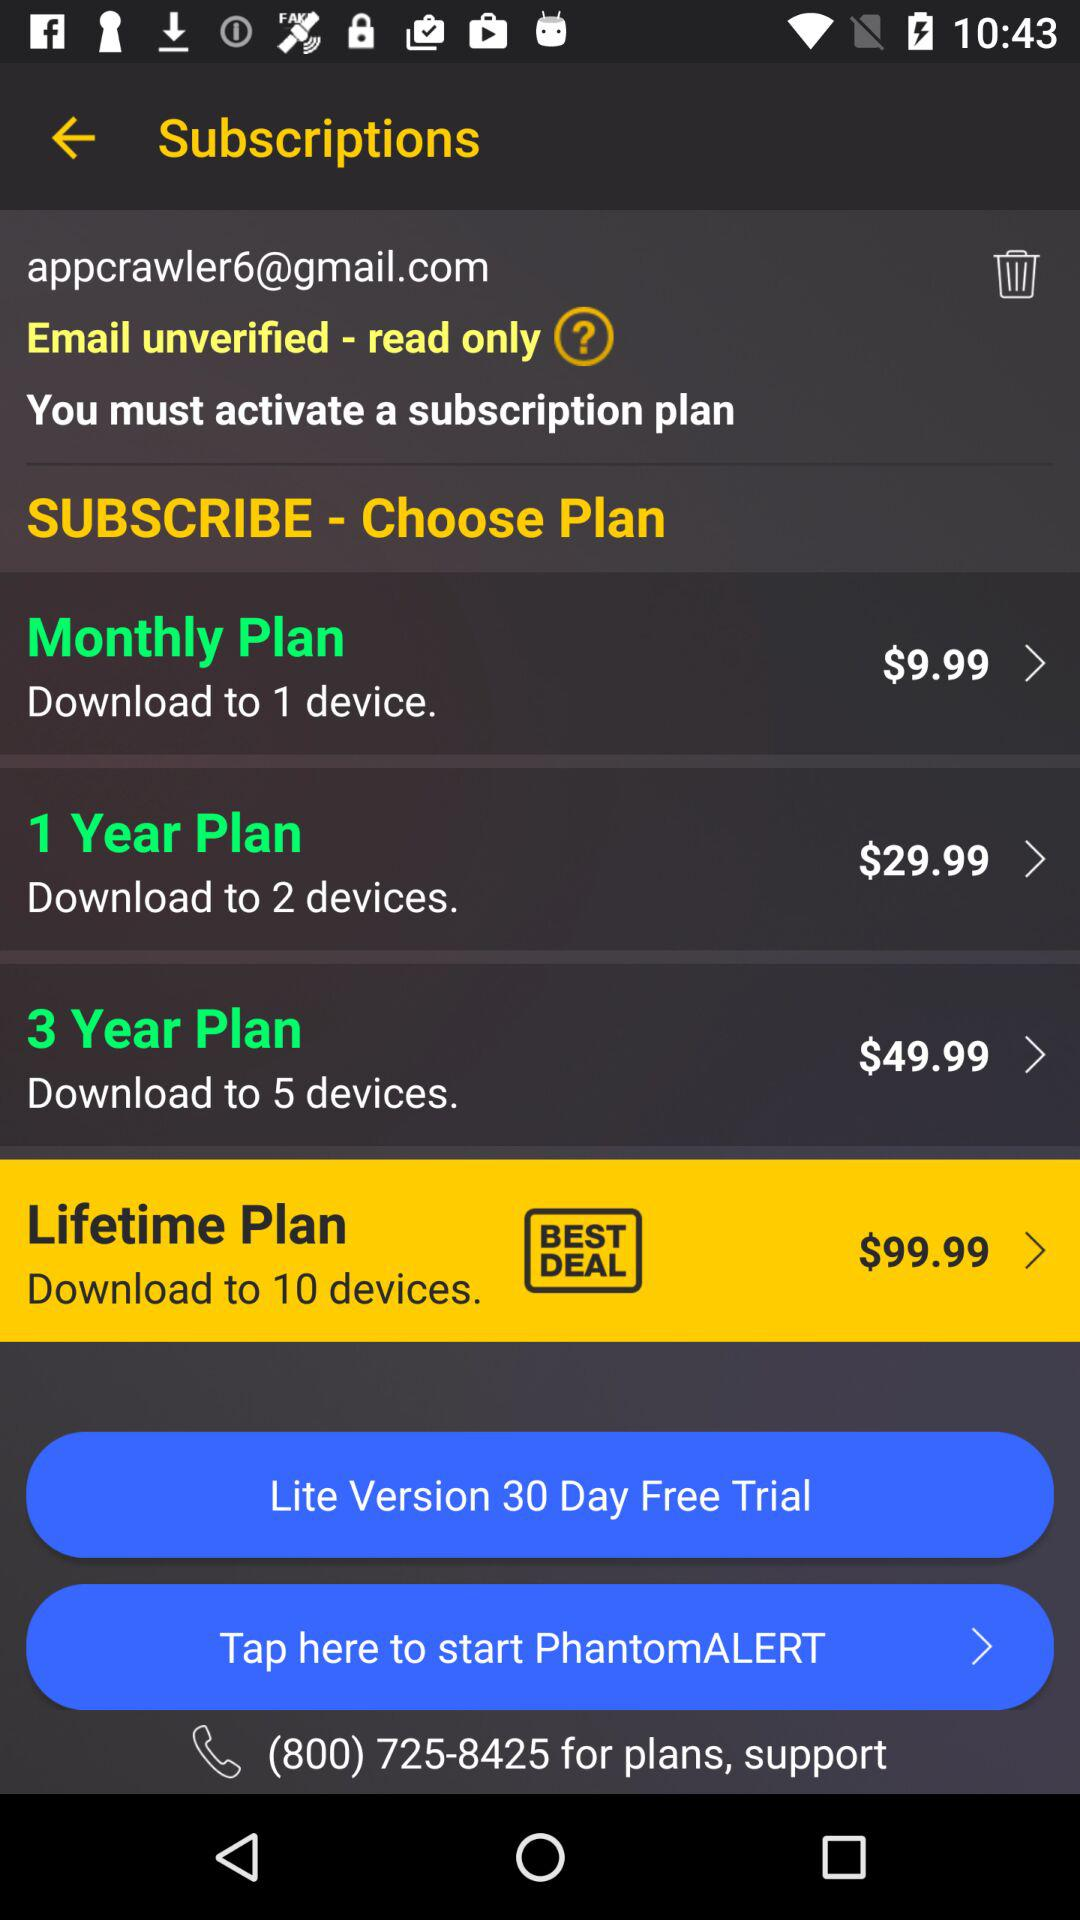How long is the free trial period for the lite version? The free trial period for the lite version is 30 days. 